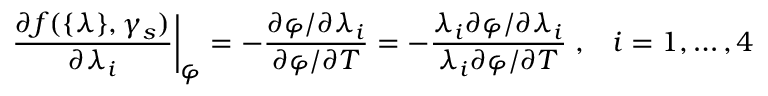<formula> <loc_0><loc_0><loc_500><loc_500>\frac { \partial f ( \{ \lambda \} , \gamma _ { s } ) } { \partial \lambda _ { i } } \right | _ { \varphi } = - \frac { \partial \varphi / \partial \lambda _ { i } } { \partial \varphi / \partial T } = - \frac { \lambda _ { i } \partial \varphi / \partial \lambda _ { i } } { \lambda _ { i } \partial \varphi / \partial T } \, , \, i = 1 , \dots , 4</formula> 